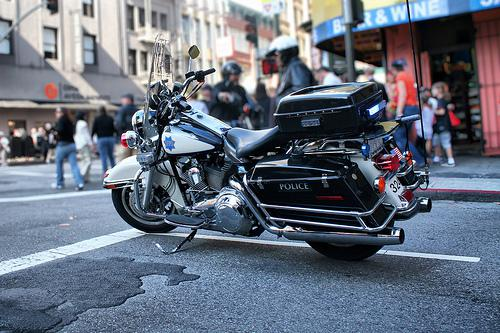Question: who is behind the motorcycle?
Choices:
A. Policeman.
B. A dog.
C. A child.
D. A woman.
Answer with the letter. Answer: A Question: what is in the picture?
Choices:
A. Atv.
B. Motorcycle.
C. Car.
D. Scooter.
Answer with the letter. Answer: B Question: what does it say on the motorcycle?
Choices:
A. Harley.
B. Police.
C. Honda.
D. Victory.
Answer with the letter. Answer: B 